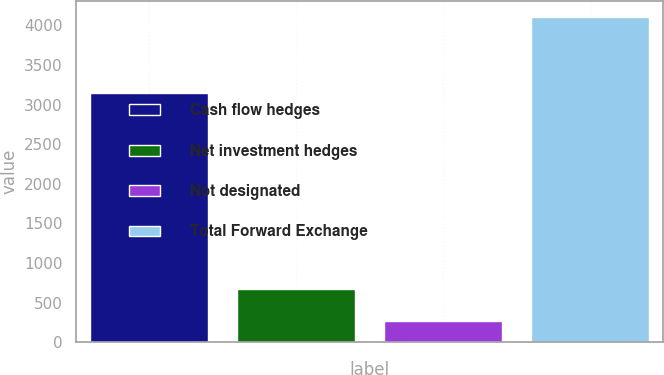Convert chart to OTSL. <chart><loc_0><loc_0><loc_500><loc_500><bar_chart><fcel>Cash flow hedges<fcel>Net investment hedges<fcel>Not designated<fcel>Total Forward Exchange<nl><fcel>3150.2<fcel>675.5<fcel>273.8<fcel>4099.5<nl></chart> 